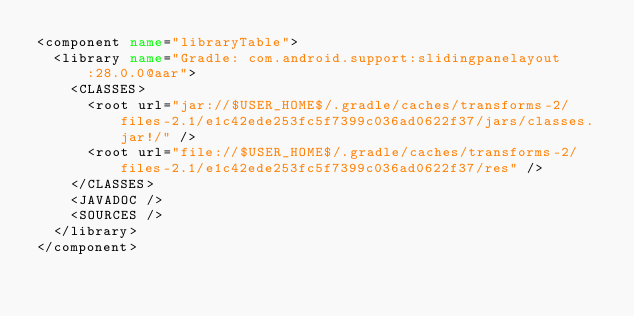Convert code to text. <code><loc_0><loc_0><loc_500><loc_500><_XML_><component name="libraryTable">
  <library name="Gradle: com.android.support:slidingpanelayout:28.0.0@aar">
    <CLASSES>
      <root url="jar://$USER_HOME$/.gradle/caches/transforms-2/files-2.1/e1c42ede253fc5f7399c036ad0622f37/jars/classes.jar!/" />
      <root url="file://$USER_HOME$/.gradle/caches/transforms-2/files-2.1/e1c42ede253fc5f7399c036ad0622f37/res" />
    </CLASSES>
    <JAVADOC />
    <SOURCES />
  </library>
</component></code> 